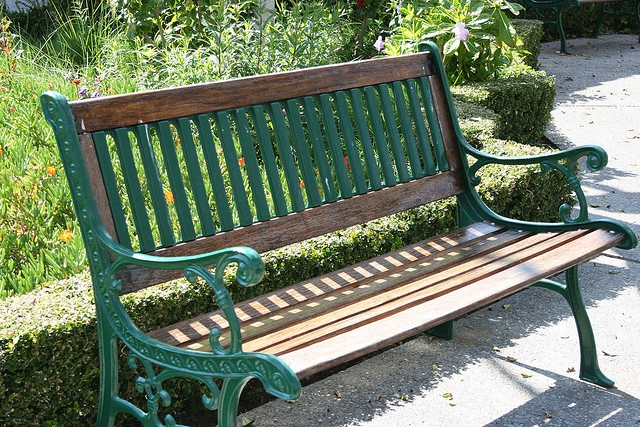Describe the objects in this image and their specific colors. I can see a bench in teal, black, gray, and ivory tones in this image. 